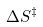Convert formula to latex. <formula><loc_0><loc_0><loc_500><loc_500>\Delta S ^ { \ddagger }</formula> 